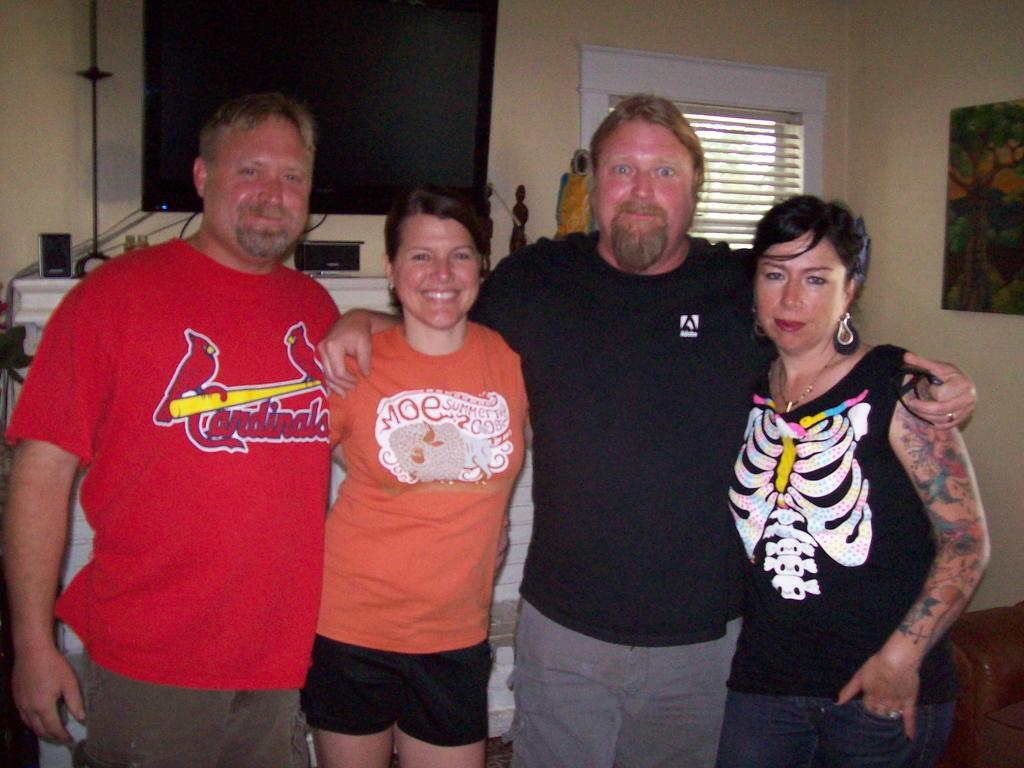<image>
Present a compact description of the photo's key features. Two men and two women pose for a photograph, the man in the red  top has cardinals on the front. 